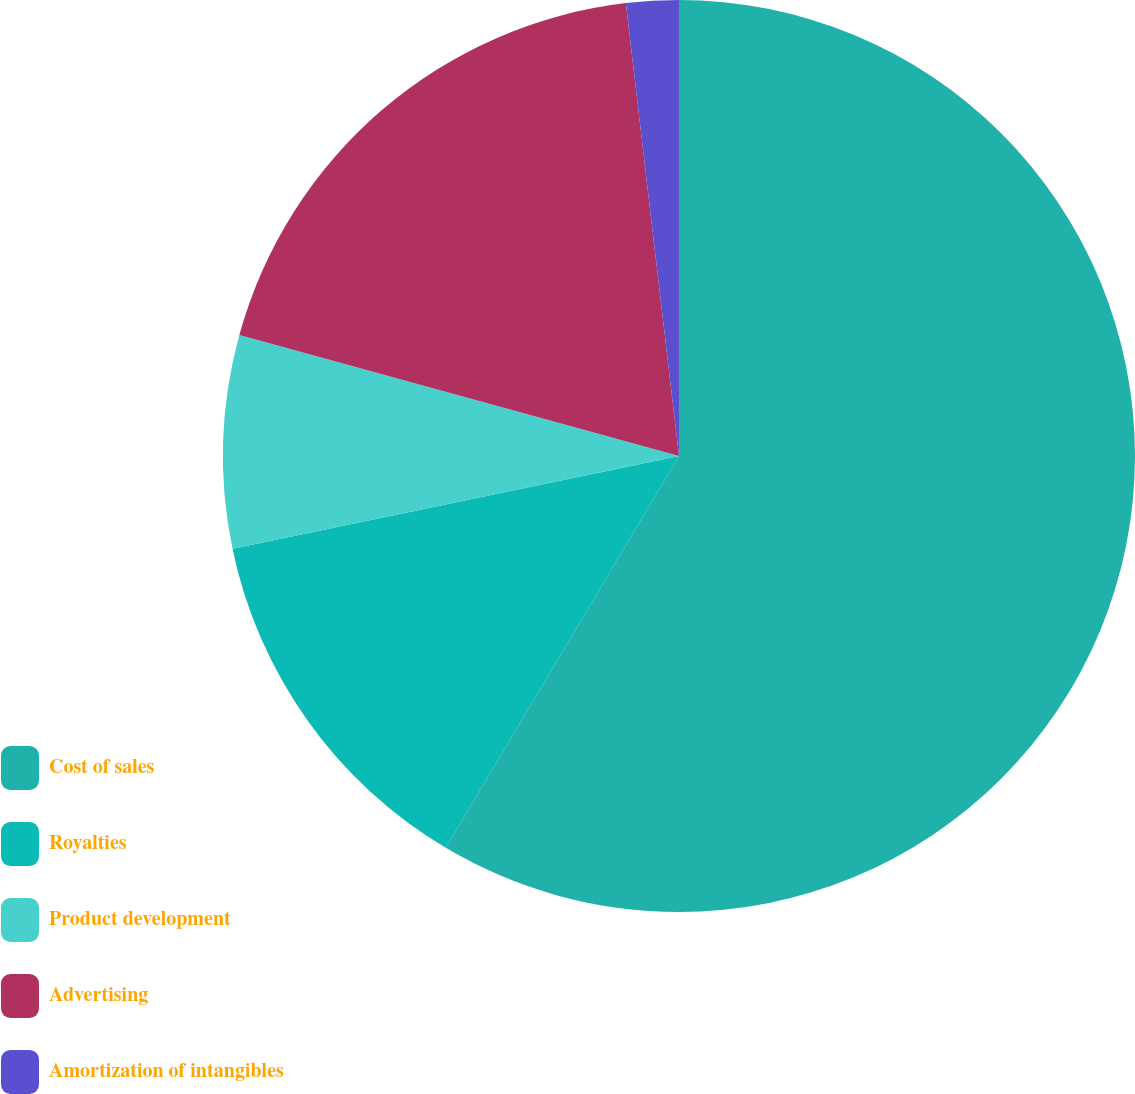<chart> <loc_0><loc_0><loc_500><loc_500><pie_chart><fcel>Cost of sales<fcel>Royalties<fcel>Product development<fcel>Advertising<fcel>Amortization of intangibles<nl><fcel>58.55%<fcel>13.2%<fcel>7.53%<fcel>18.87%<fcel>1.86%<nl></chart> 